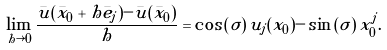Convert formula to latex. <formula><loc_0><loc_0><loc_500><loc_500>\lim _ { h \rightarrow 0 } \frac { \bar { u } ( \bar { x } _ { 0 } + h \bar { e } _ { j } ) - \bar { u } ( \bar { x } _ { 0 } ) } { h } = \cos \left ( \sigma \right ) u _ { j } ( x _ { 0 } ) - \sin \left ( \sigma \right ) x _ { 0 } ^ { j } .</formula> 